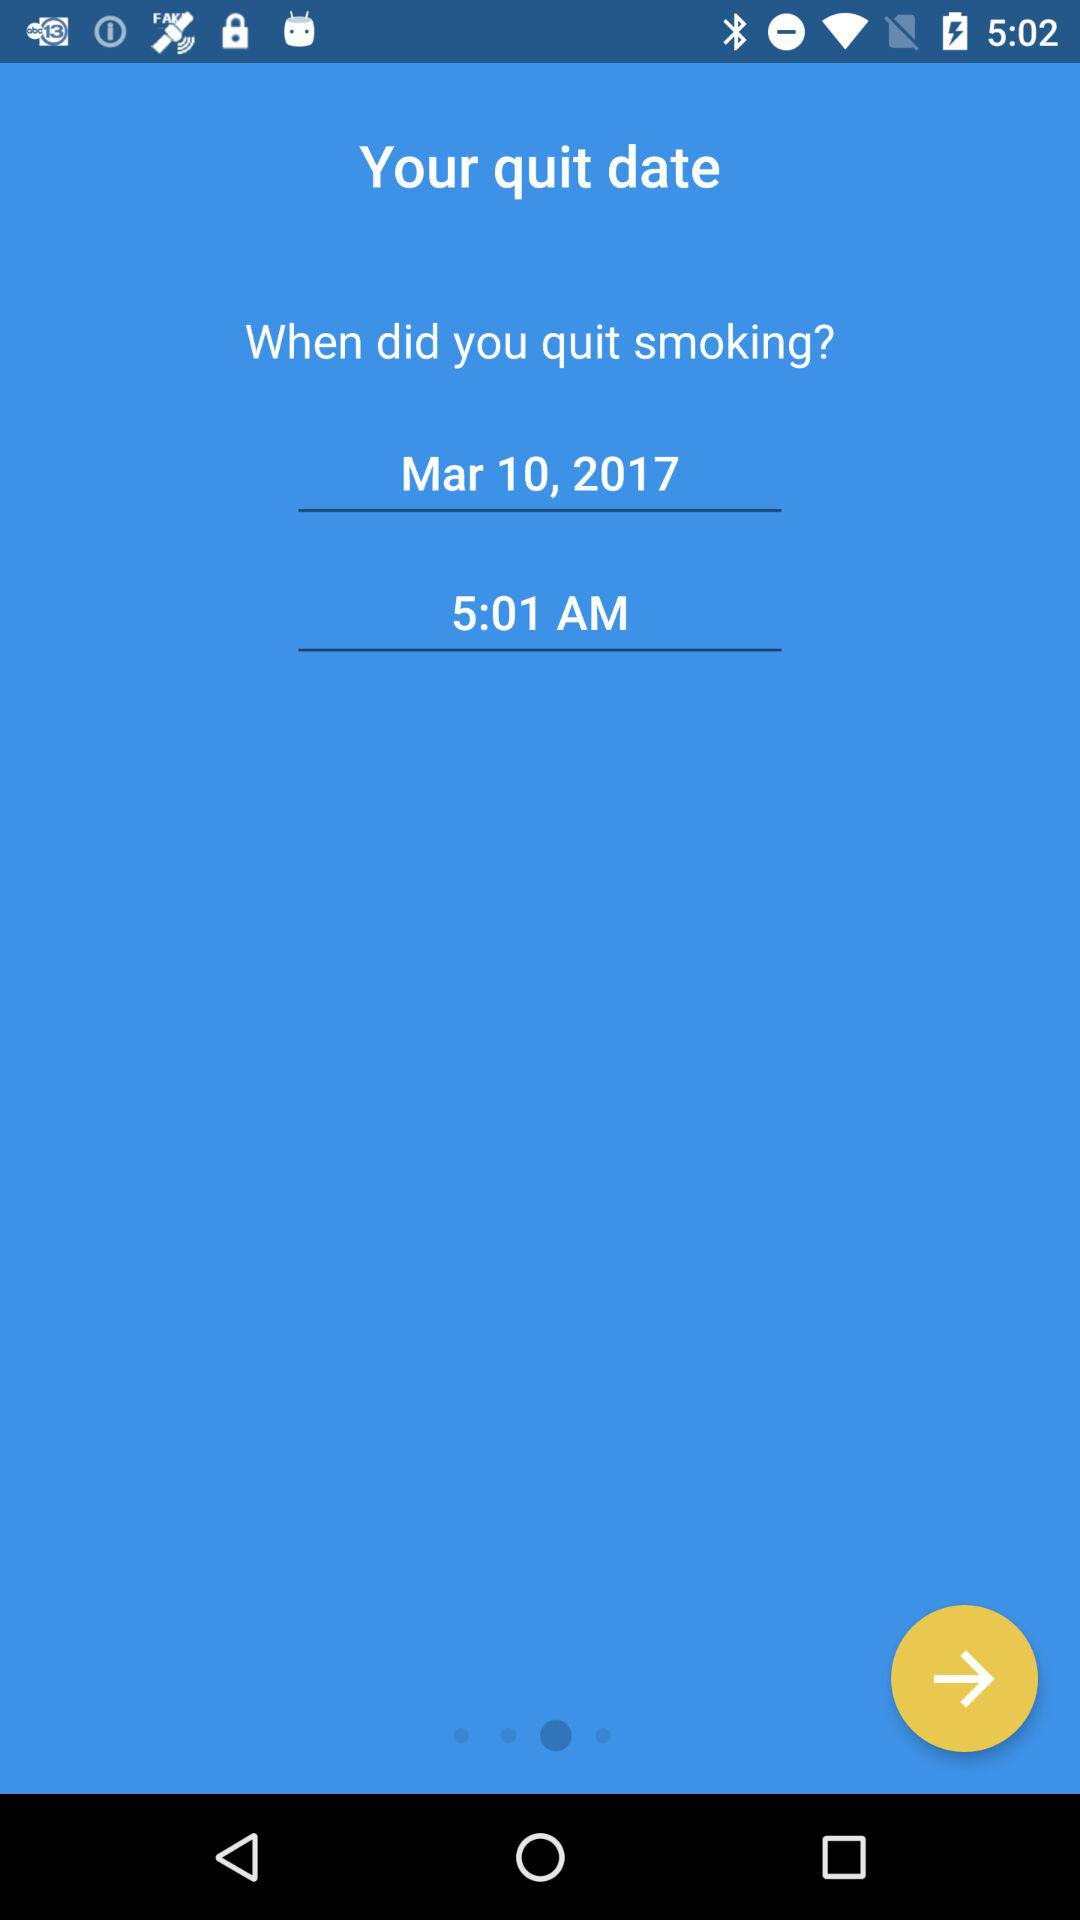How many hours after midnight did you quit smoking?
Answer the question using a single word or phrase. 5 